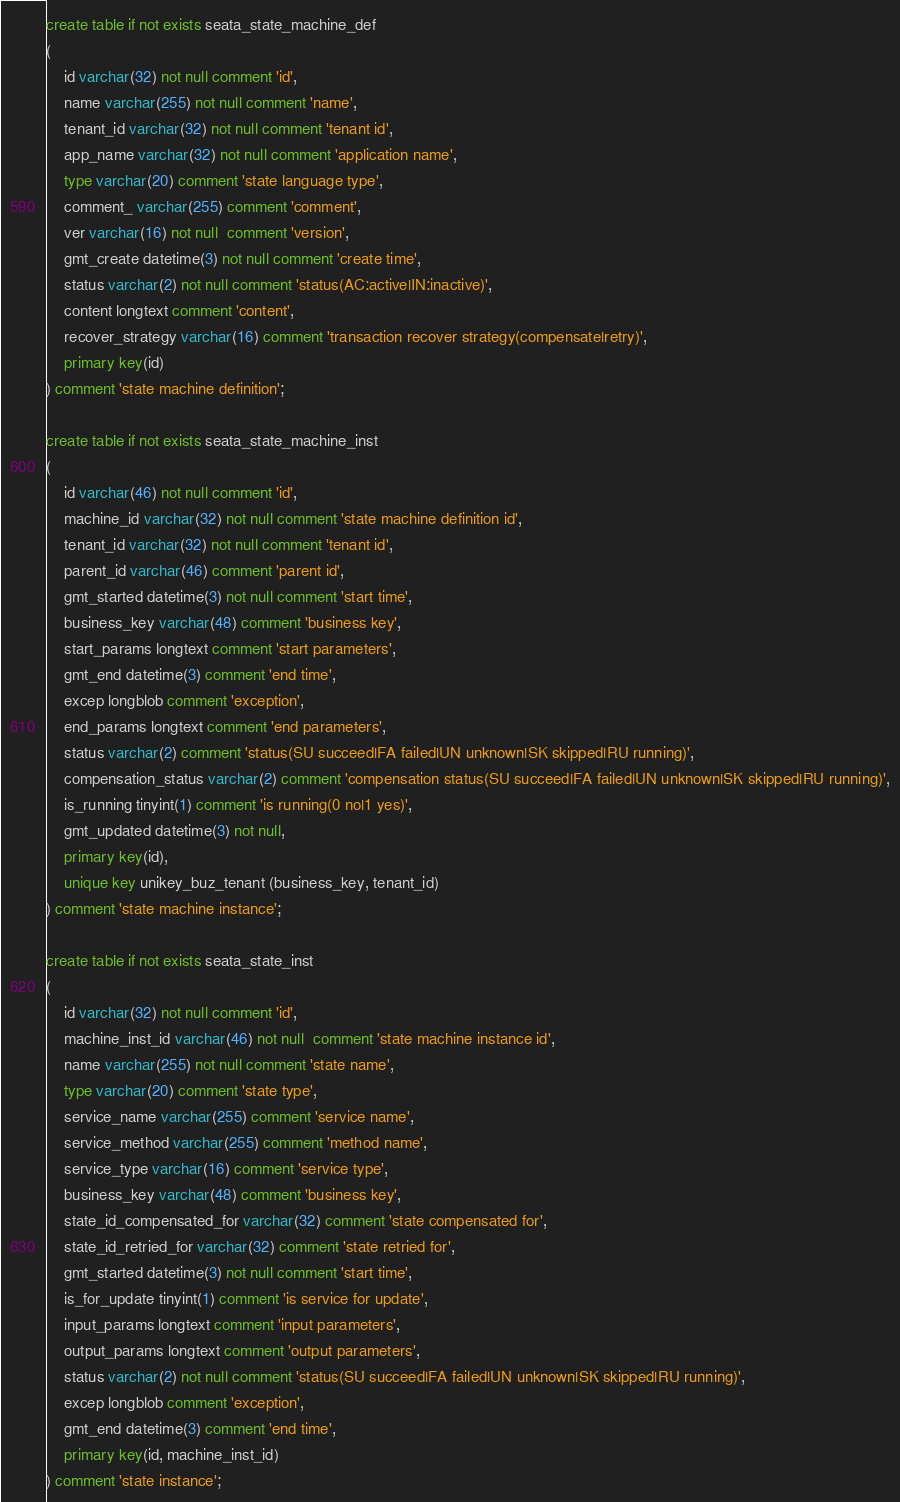<code> <loc_0><loc_0><loc_500><loc_500><_SQL_>create table if not exists seata_state_machine_def
(
    id varchar(32) not null comment 'id',
    name varchar(255) not null comment 'name',
    tenant_id varchar(32) not null comment 'tenant id',
    app_name varchar(32) not null comment 'application name',
    type varchar(20) comment 'state language type',
    comment_ varchar(255) comment 'comment',
    ver varchar(16) not null  comment 'version',
    gmt_create datetime(3) not null comment 'create time',
    status varchar(2) not null comment 'status(AC:active|IN:inactive)',
    content longtext comment 'content',
    recover_strategy varchar(16) comment 'transaction recover strategy(compensate|retry)',
    primary key(id)
) comment 'state machine definition';

create table if not exists seata_state_machine_inst
(
    id varchar(46) not null comment 'id',
    machine_id varchar(32) not null comment 'state machine definition id',
    tenant_id varchar(32) not null comment 'tenant id',
    parent_id varchar(46) comment 'parent id',
    gmt_started datetime(3) not null comment 'start time',
    business_key varchar(48) comment 'business key',
    start_params longtext comment 'start parameters',
    gmt_end datetime(3) comment 'end time',
    excep longblob comment 'exception',
    end_params longtext comment 'end parameters',
    status varchar(2) comment 'status(SU succeed|FA failed|UN unknown|SK skipped|RU running)',
    compensation_status varchar(2) comment 'compensation status(SU succeed|FA failed|UN unknown|SK skipped|RU running)',
    is_running tinyint(1) comment 'is running(0 no|1 yes)',
    gmt_updated datetime(3) not null,
    primary key(id),
    unique key unikey_buz_tenant (business_key, tenant_id)
) comment 'state machine instance';

create table if not exists seata_state_inst
(
    id varchar(32) not null comment 'id',
    machine_inst_id varchar(46) not null  comment 'state machine instance id',
    name varchar(255) not null comment 'state name',
    type varchar(20) comment 'state type',
    service_name varchar(255) comment 'service name',
    service_method varchar(255) comment 'method name',
    service_type varchar(16) comment 'service type',
    business_key varchar(48) comment 'business key',
    state_id_compensated_for varchar(32) comment 'state compensated for',
    state_id_retried_for varchar(32) comment 'state retried for',
    gmt_started datetime(3) not null comment 'start time',
    is_for_update tinyint(1) comment 'is service for update',
    input_params longtext comment 'input parameters',
    output_params longtext comment 'output parameters',
    status varchar(2) not null comment 'status(SU succeed|FA failed|UN unknown|SK skipped|RU running)',
    excep longblob comment 'exception',
    gmt_end datetime(3) comment 'end time',
    primary key(id, machine_inst_id)
) comment 'state instance';</code> 